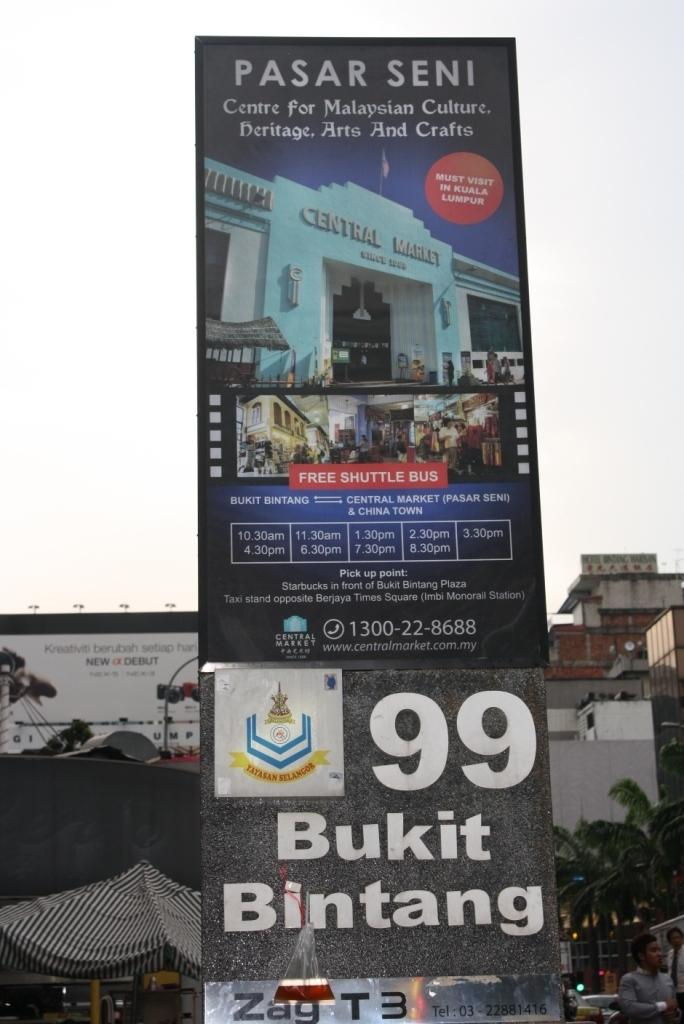<image>
Share a concise interpretation of the image provided. Central Market is being advertised on this billboard. 